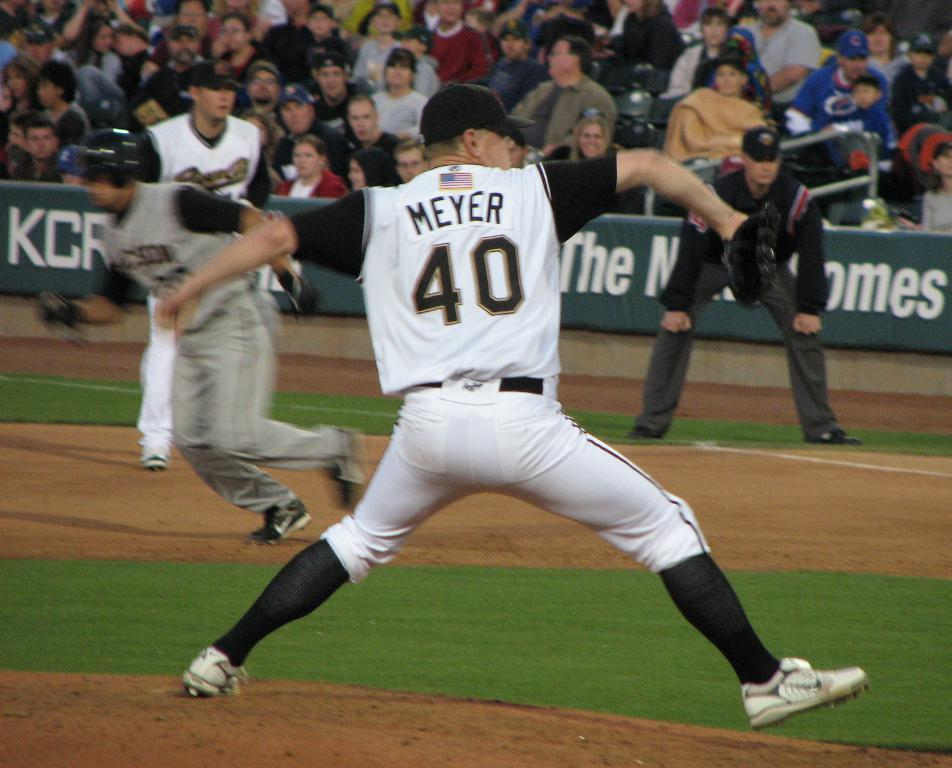Provide a one-sentence caption for the provided image. A baseball pitcher called Meyer and numbered 48 throws a ball as runners scamper in the background in an action packed shot. 